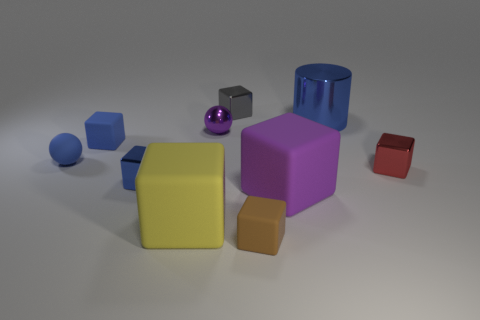What color is the shiny cube that is in front of the small gray thing and left of the big purple thing?
Make the answer very short. Blue. Does the blue metal object that is behind the tiny blue matte sphere have the same size as the block on the left side of the blue shiny block?
Your answer should be very brief. No. How many things are either small blocks that are right of the yellow rubber object or blocks?
Your response must be concise. 7. What is the red cube made of?
Provide a short and direct response. Metal. Do the brown matte cube and the yellow rubber block have the same size?
Make the answer very short. No. How many cylinders are either tiny brown things or tiny red shiny things?
Provide a succinct answer. 0. What is the color of the small cube that is left of the metallic block that is left of the large yellow cube?
Your answer should be very brief. Blue. Are there fewer large purple cubes behind the tiny gray object than big blue metallic objects that are to the right of the blue matte sphere?
Your answer should be very brief. Yes. There is a blue shiny cylinder; is its size the same as the purple thing that is left of the tiny brown rubber object?
Give a very brief answer. No. The big object that is both left of the big metal cylinder and right of the small gray object has what shape?
Keep it short and to the point. Cube. 